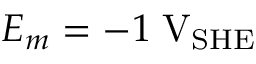Convert formula to latex. <formula><loc_0><loc_0><loc_500><loc_500>E _ { m } = - 1 \, V _ { S H E }</formula> 